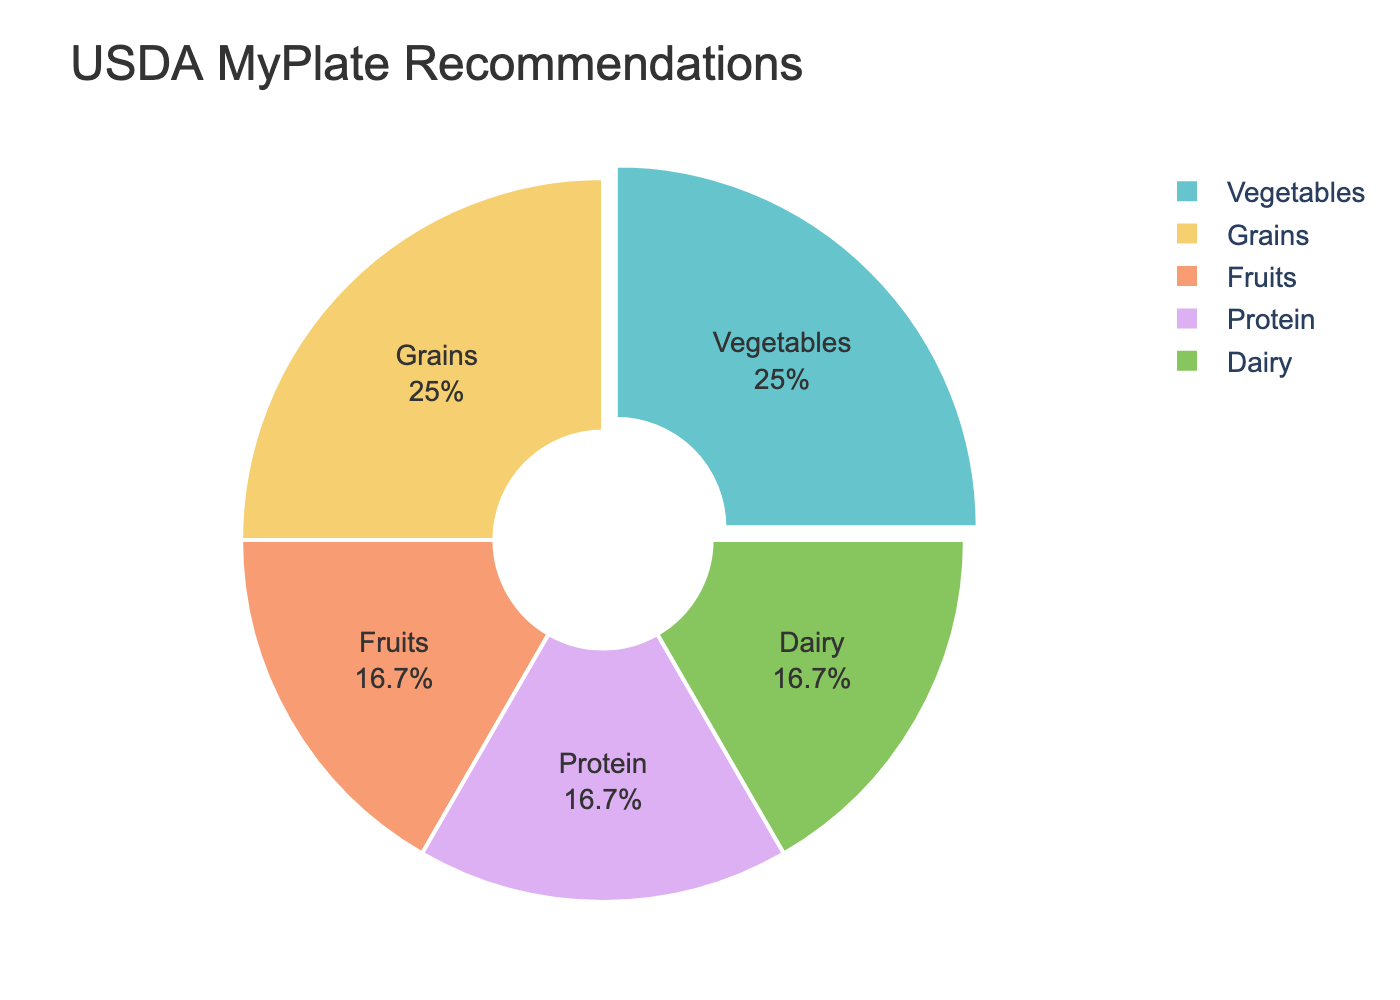What's the total proportion of Fruits and Vegetables? Adding the proportions of the Fruits and Vegetables (20% + 30%) gives us the total proportion.
Answer: 50% Which food group has the largest proportion, and what is it? From the figure, we can see that both Vegetables and Grains have the largest proportion at 30% each.
Answer: Vegetables and Grains, 30% Are Fruits and Protein recommended in equal proportions? By looking at the figure, we can confirm that both Fruits and Protein have a proportion of 20%.
Answer: Yes Is the proportion of Dairy greater than the proportion of Fruits? The figure shows that both Dairy and Fruits have the same proportion of 20%, so Dairy is not greater than Fruits.
Answer: No What's the sum of the proportions recommended for Grains and Dairy? By adding the proportions of Grains and Dairy (30% + 20%), we get the sum.
Answer: 50% Compare the proportion of Vegetables to Protein. Which is larger, and by how much? By subtracting the proportion of Protein (20%) from Vegetables (30%), we find the difference.
Answer: Vegetables, by 10% What is the smallest food group proportion, and what is it? From the figure, we can see that both Fruits, Protein, and Dairy have the smallest proportion at 20% each.
Answer: Fruits, Protein, and Dairy, 20% Is the proportion of Grains equal to the combined proportion of Fruits and Protein? By adding the proportions of Fruits and Protein (20% + 20%), we get 40%, which is greater than the proportion of Grains (30%).
Answer: No What percentage of the chart is dedicated to Protein? The figure shows the proportion of Protein, which is 20% of the chart.
Answer: 20% Find the difference between the highest and lowest food group proportions. From the figure, the highest proportion is 30% (Vegetables and Grains), and the lowest is 20% (Fruits, Protein, and Dairy). The difference is 30% - 20%.
Answer: 10% 